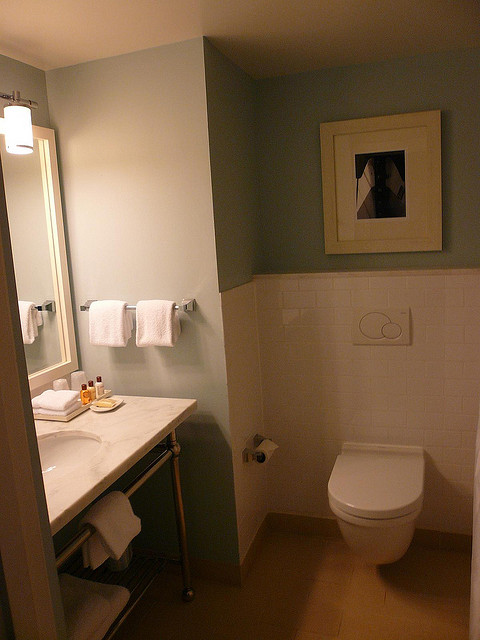<image>Where are the toiletries? I am not sure where the toiletries are. They could be on the vanity beside the sink or in the bathroom cabinet. Where are the toiletries? I don't know where the toiletries are. They can be on the vanity beside the sink, on the counter, or in the cabinet. 